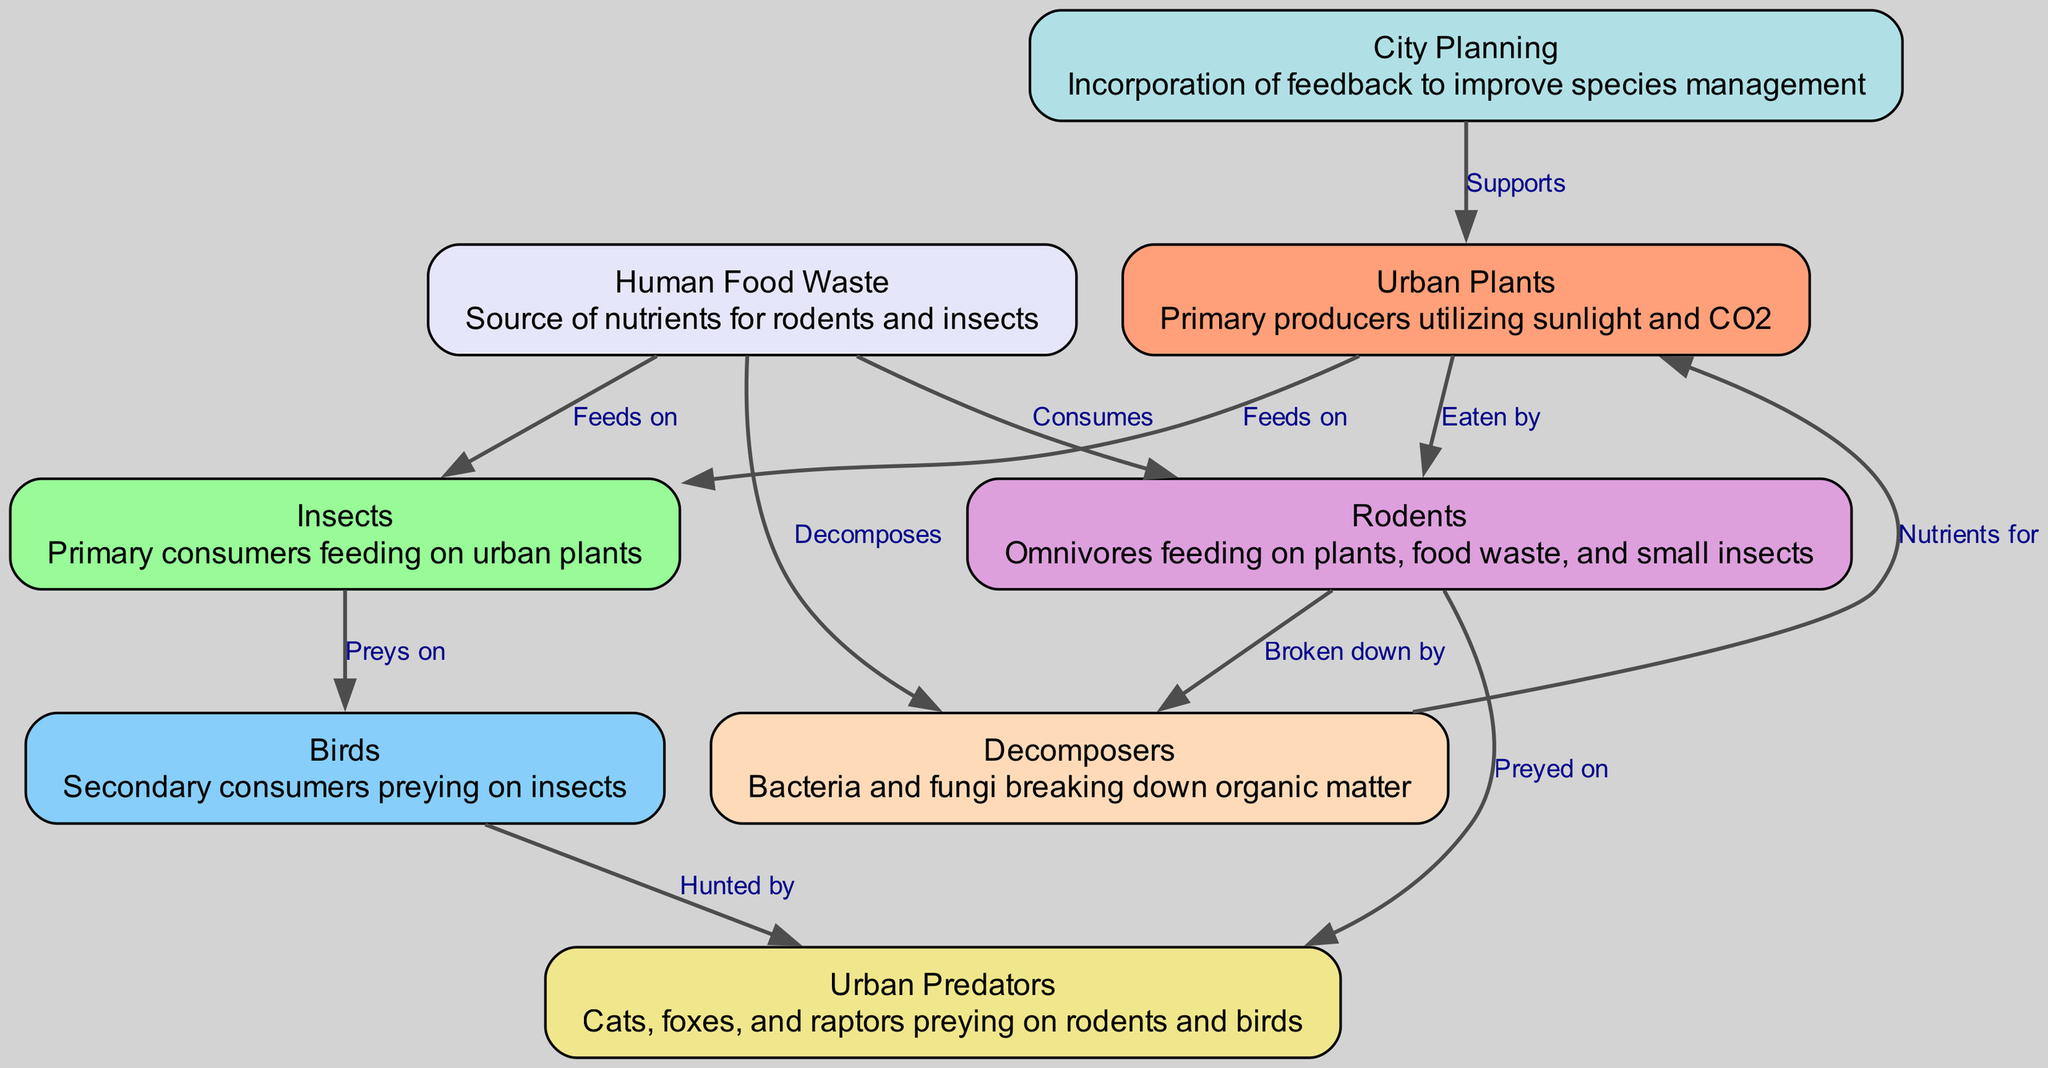What are the primary producers in the urban food chain? The diagram shows "Urban Plants" as the primary producers at the start of the food chain, utilizing sunlight and CO2.
Answer: Urban Plants How many nodes are there in total in the diagram? By counting the nodes listed in the data section, there are a total of 8 nodes defined in the urban food chain.
Answer: 8 Which node feeds on "Urban Plants"? Referring to the edges, both "Insects" and "Rodents" are indicated as feeding on "Urban Plants" in the diagram.
Answer: Insects, Rodents What is the relationship between "Decomposers" and "Urban Plants"? The diagram indicates a directional edge from "Decomposers" to "Urban Plants", which means that decomposers provide nutrients back to the primary producers.
Answer: Nutrients for Who are the secondary consumers in the urban food chain? Looking at the nodes, "Birds" are described as the secondary consumers, preying on "Insects".
Answer: Birds What do "Rodents" consume according to the diagram? The edges illustrate that "Rodents" consume both "Human Food Waste" and "Urban Plants", indicating their omnivorous diet.
Answer: Human Food Waste, Urban Plants How does "City Planning" support "Urban Plants"? The diagram shows a direct link from "City Planning" to "Urban Plants", suggesting that the focus on species management and ecological feedback leads to improved growth or management of urban flora.
Answer: Supports Which group is at the top of the food chain? By analyzing the connections, "Urban Predators", which include cats, foxes, and raptors, are at the top, preying on both "Rodents" and "Birds".
Answer: Urban Predators Which nodes indicate a waste management role? "Human Food Waste" serves as a nutrient source for several organisms, while "Decomposers" break down organic matter, reflecting key aspects of waste management in the urban ecosystem.
Answer: Human Food Waste, Decomposers 